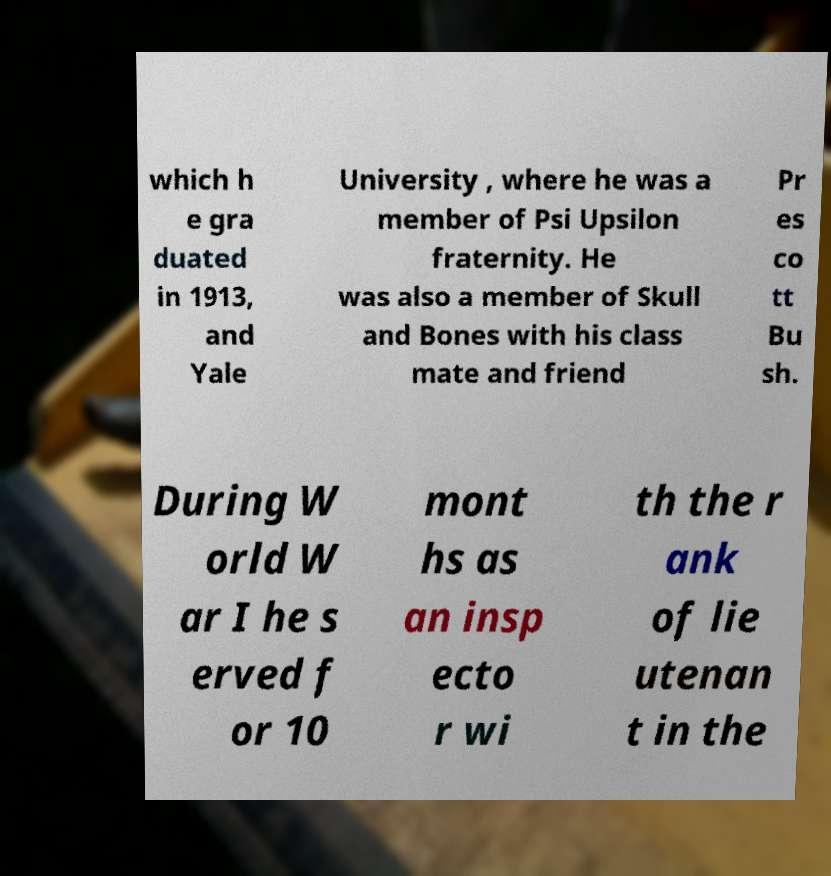I need the written content from this picture converted into text. Can you do that? which h e gra duated in 1913, and Yale University , where he was a member of Psi Upsilon fraternity. He was also a member of Skull and Bones with his class mate and friend Pr es co tt Bu sh. During W orld W ar I he s erved f or 10 mont hs as an insp ecto r wi th the r ank of lie utenan t in the 